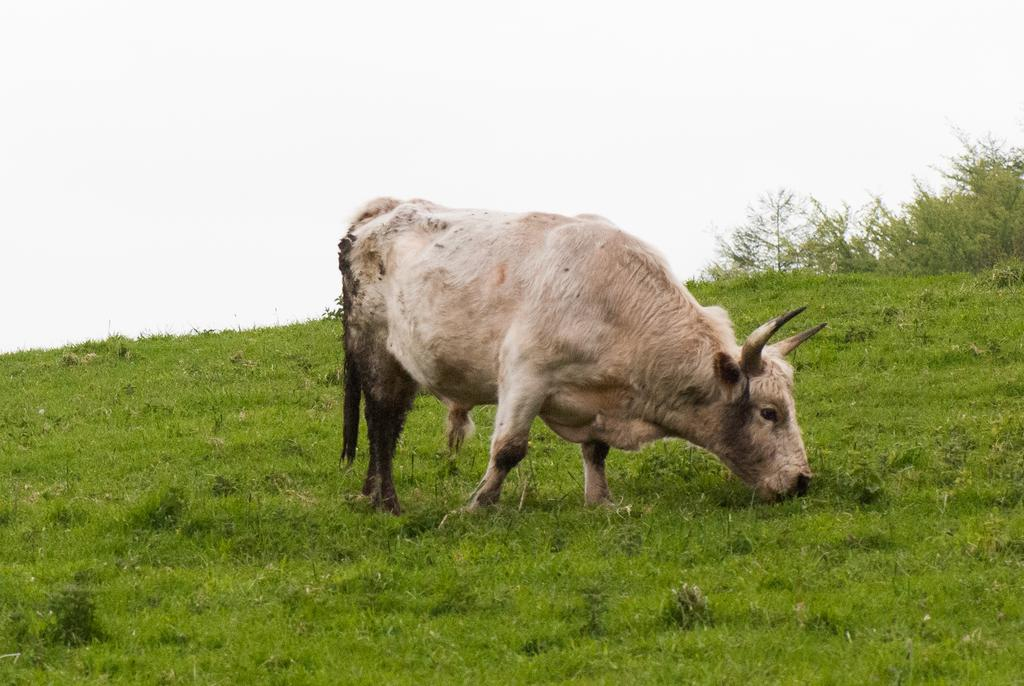What type of animal can be seen in the image? There is an animal in the image, and it has a white and brown color. What is the animal doing in the image? The animal is standing and eating grass in the image. What type of vegetation is present in the image? There are plants in the image, and they are green in color. What can be seen in the background of the image? The sky is visible in the image, and it is white in color. What type of knife is being used to cut the dinner in the image? There is no knife or dinner present in the image; it features an animal eating grass and plants. What type of expansion is visible in the image? There is no expansion visible in the image; it features an animal, plants, and the sky. 